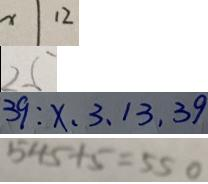<formula> <loc_0><loc_0><loc_500><loc_500>x \vert 1 2 
 2 5 
 3 9 : x , 3 , 1 3 , 3 9 
 5 4 5 + 5 = 5 5 0</formula> 